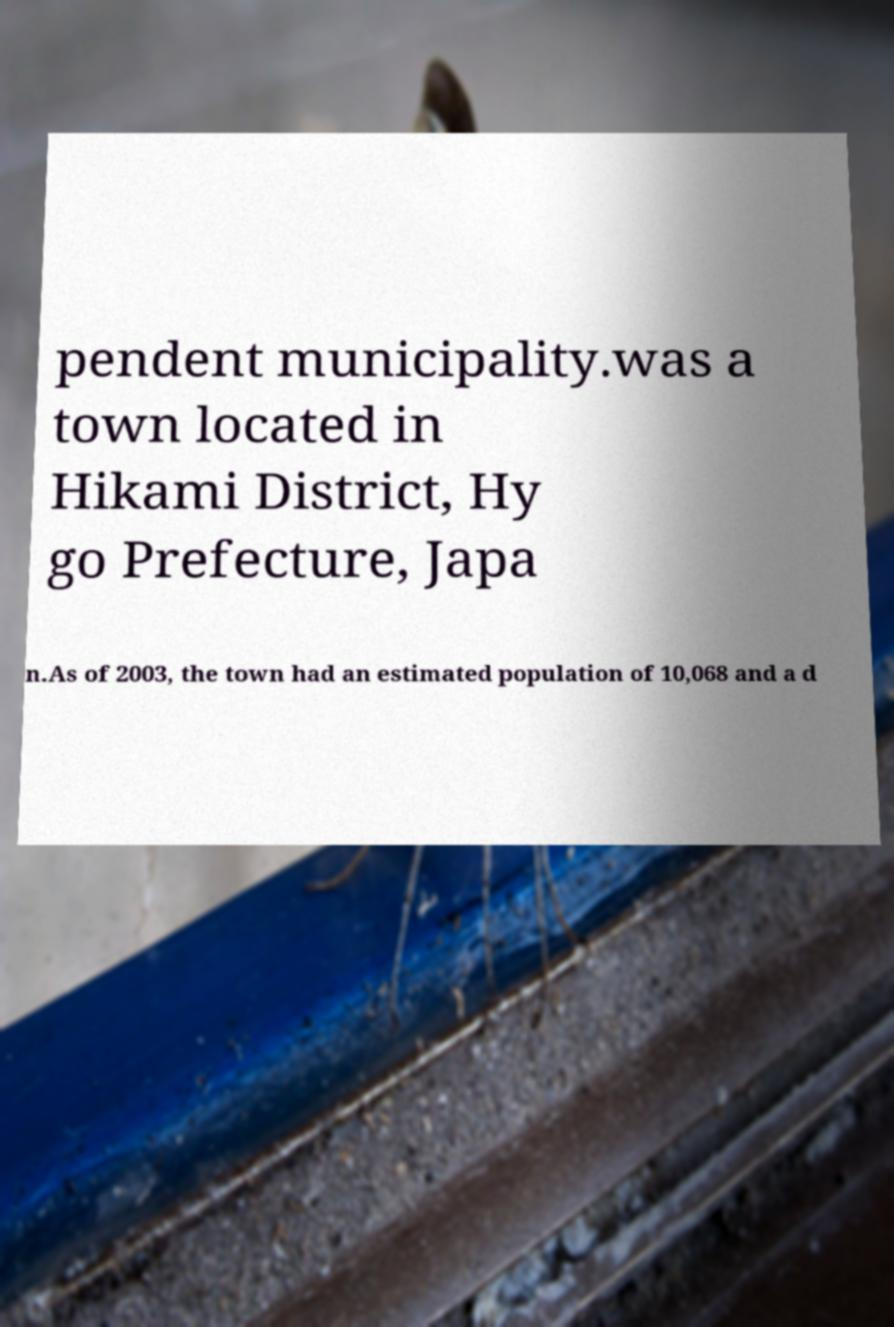What messages or text are displayed in this image? I need them in a readable, typed format. pendent municipality.was a town located in Hikami District, Hy go Prefecture, Japa n.As of 2003, the town had an estimated population of 10,068 and a d 